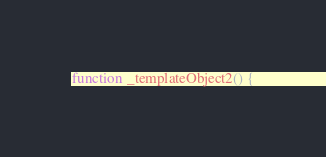Convert code to text. <code><loc_0><loc_0><loc_500><loc_500><_JavaScript_>function _templateObject2() {</code> 